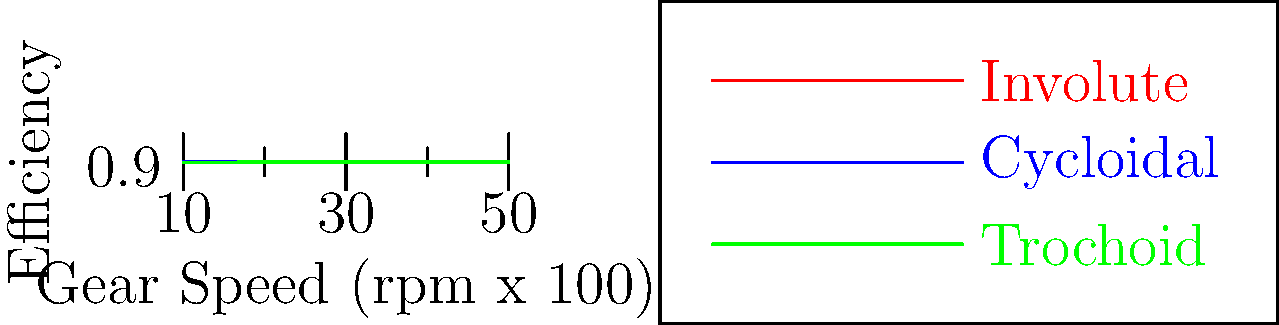Based on the efficiency curves for different gear tooth profiles shown in the graph, which profile would you recommend for a high-speed power transmission system operating at 4000 rpm, and why might this choice be significant in the context of medical equipment design? To answer this question, let's analyze the graph step-by-step:

1. The graph shows efficiency curves for three different gear tooth profiles: Involute (red), Cycloidal (blue), and Trochoid (green).

2. The x-axis represents gear speed in hundreds of rpm, so 4000 rpm corresponds to 40 on the x-axis.

3. At 4000 rpm (x = 40):
   - Involute profile: Efficiency ≈ 0.98
   - Cycloidal profile: Efficiency ≈ 0.94
   - Trochoid profile: Efficiency ≈ 0.91

4. The Involute profile shows the highest efficiency at 4000 rpm.

5. In the context of medical equipment design:
   a) Higher efficiency means less energy loss, which is crucial for battery-powered devices or reducing heat generation.
   b) Reduced heat generation is important in sterile environments or when working with temperature-sensitive materials.
   c) Consistent performance at high speeds is vital for precise control in medical devices.
   d) The involute profile's superior efficiency could lead to more compact and lightweight designs, which is beneficial for portable medical equipment.

6. From a research perspective on the social implications of penicillin:
   a) More efficient medical equipment could lead to improved accessibility and affordability of treatments.
   b) Energy-efficient designs contribute to sustainability in healthcare, aligning with broader social and environmental concerns.
   c) Reliable, high-performance medical equipment can enhance the effectiveness of antibiotic treatments, potentially reducing the development of antibiotic resistance.

Therefore, the Involute gear tooth profile would be recommended for a high-speed power transmission system operating at 4000 rpm due to its superior efficiency, which has significant implications for medical equipment design and, by extension, the social impact of medical treatments like penicillin administration.
Answer: Involute profile, due to highest efficiency at 4000 rpm, benefiting medical equipment design through energy savings, heat reduction, and improved performance. 